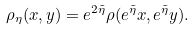<formula> <loc_0><loc_0><loc_500><loc_500>\rho _ { \eta } ( x , y ) = e ^ { 2 \tilde { \eta } } \rho ( e ^ { \tilde { \eta } } x , e ^ { \tilde { \eta } } y ) .</formula> 